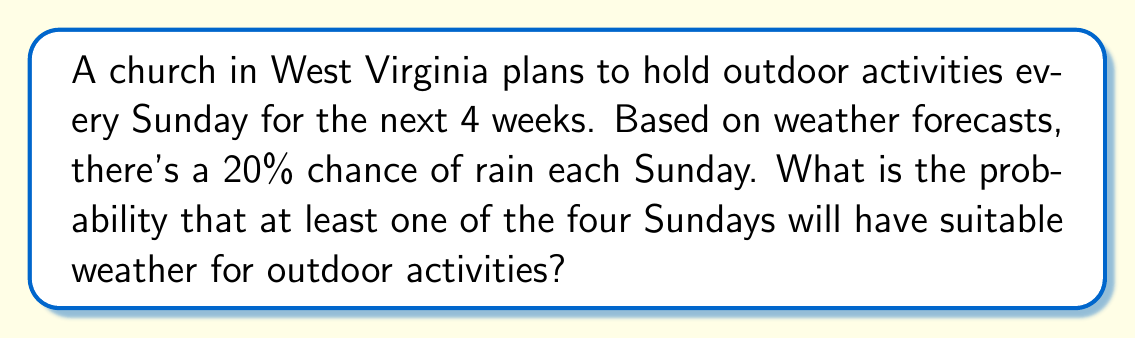Can you answer this question? Let's approach this step-by-step:

1) First, we need to find the probability of suitable weather on a single Sunday. Since there's a 20% chance of rain, the probability of suitable weather is:

   $P(\text{suitable weather}) = 1 - P(\text{rain}) = 1 - 0.20 = 0.80$ or 80%

2) Now, we need to find the probability of suitable weather for all four Sundays. Since the events are independent, we multiply the probabilities:

   $P(\text{all suitable}) = 0.80 \times 0.80 \times 0.80 \times 0.80 = 0.80^4 = 0.4096$

3) The question asks for the probability of at least one Sunday with suitable weather. This is easier to calculate by finding the opposite event (no Sundays with suitable weather) and subtracting from 1:

   $P(\text{at least one suitable}) = 1 - P(\text{no suitable})$
   
   $= 1 - P(\text{all unsuitable})$
   
   $= 1 - (0.20)^4$
   
   $= 1 - 0.0016$
   
   $= 0.9984$

4) Convert to a percentage:

   $0.9984 \times 100\% = 99.84\%$

Therefore, the probability that at least one of the four Sundays will have suitable weather for outdoor activities is 99.84%.
Answer: 99.84% 